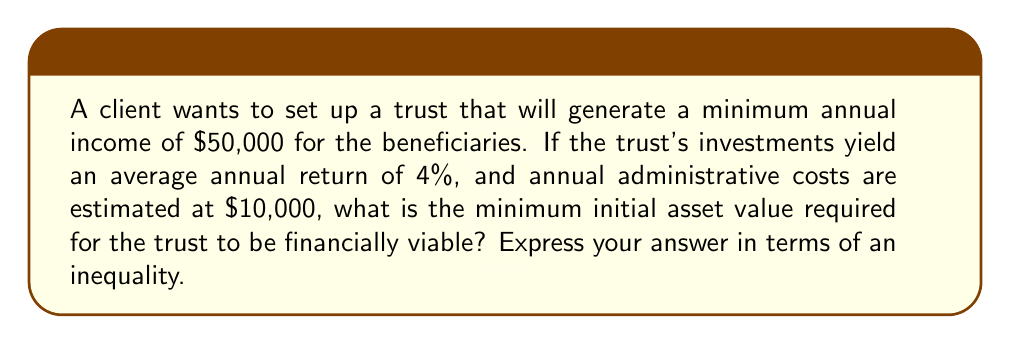Can you answer this question? Let's approach this step-by-step:

1) Let $x$ be the initial asset value of the trust.

2) The annual return on the trust's assets is 4% of $x$:
   Annual return = $0.04x$

3) For the trust to be viable, the annual return must cover both the desired income for beneficiaries ($50,000) and the administrative costs ($10,000):
   $0.04x \geq 50,000 + 10,000$

4) Simplify the right side of the inequality:
   $0.04x \geq 60,000$

5) Divide both sides by 0.04 to isolate $x$:
   $x \geq \frac{60,000}{0.04}$

6) Simplify:
   $x \geq 1,500,000$

Therefore, the minimum initial asset value required for the trust to be financially viable is $1,500,000 or greater.
Answer: $x \geq 1,500,000$ 